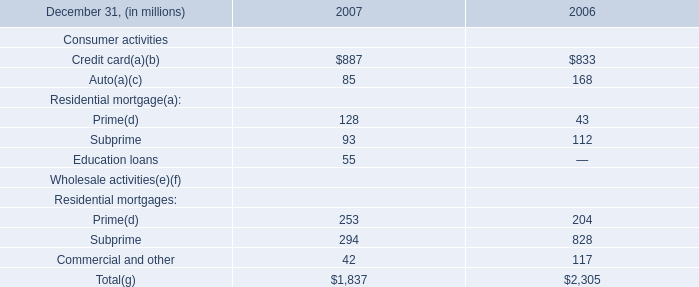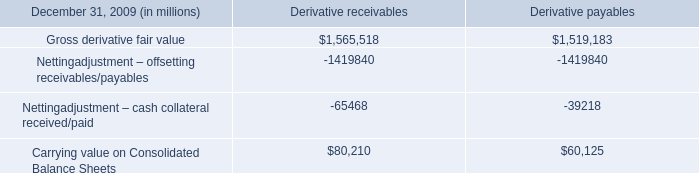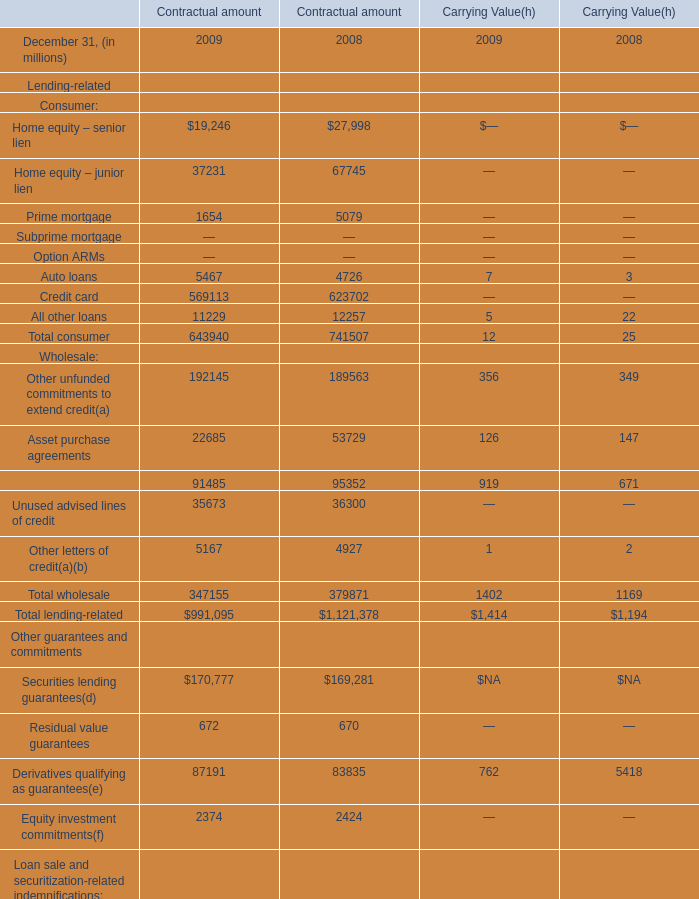What is the total amount of Nettingadjustment – offsetting receivables/payables of Derivative receivables, and Prime mortgage of Contractual amount 2009 ? 
Computations: (1419840.0 + 1654.0)
Answer: 1421494.0. 